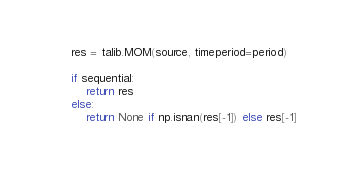<code> <loc_0><loc_0><loc_500><loc_500><_Python_>    res = talib.MOM(source, timeperiod=period)

    if sequential:
        return res
    else:
        return None if np.isnan(res[-1]) else res[-1]
</code> 